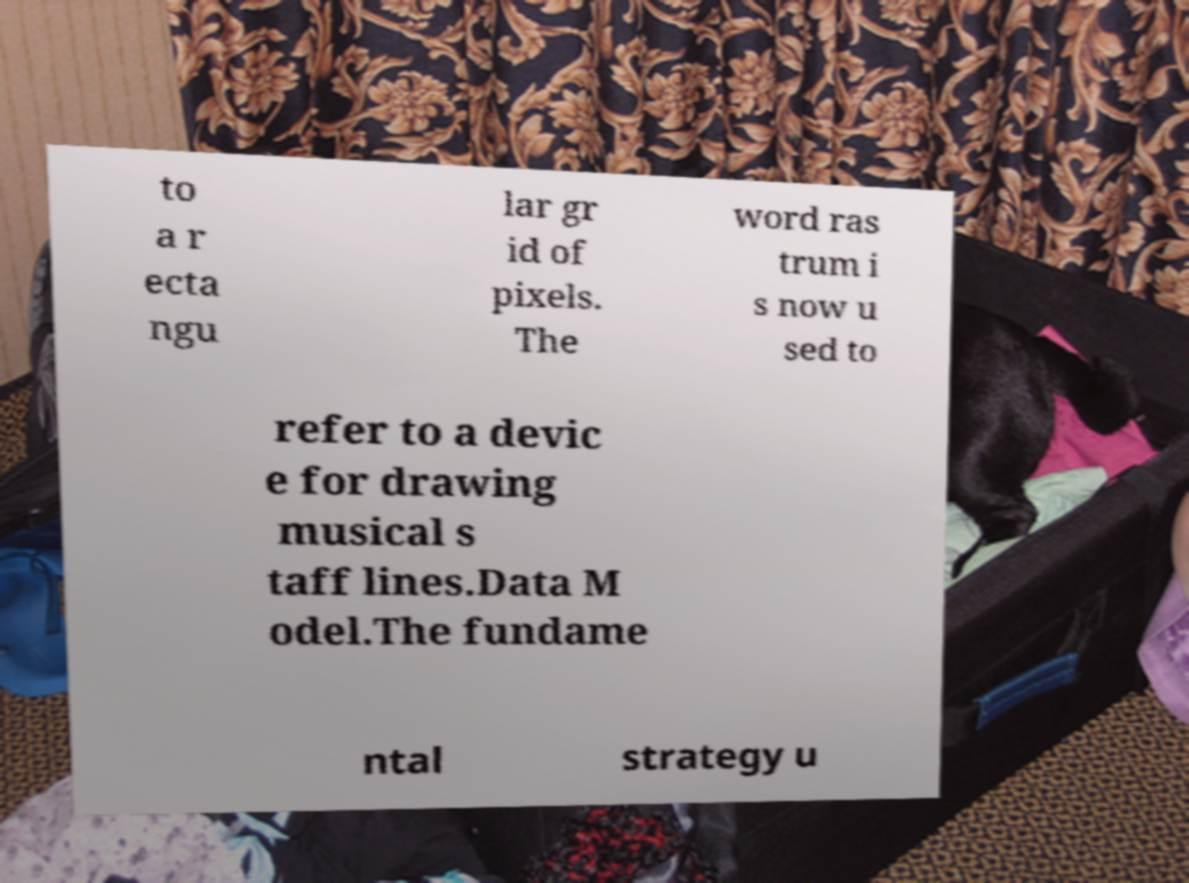For documentation purposes, I need the text within this image transcribed. Could you provide that? to a r ecta ngu lar gr id of pixels. The word ras trum i s now u sed to refer to a devic e for drawing musical s taff lines.Data M odel.The fundame ntal strategy u 